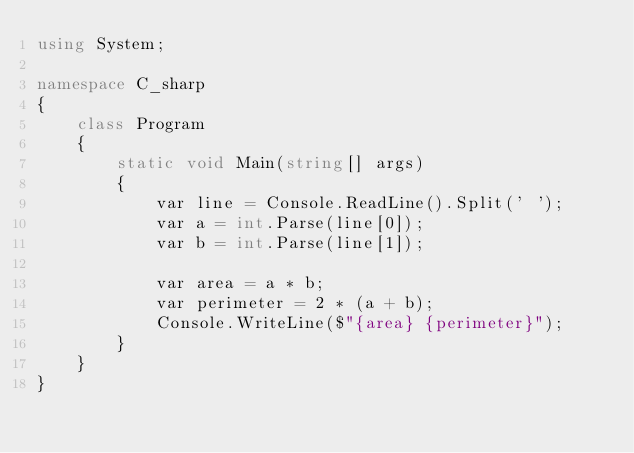Convert code to text. <code><loc_0><loc_0><loc_500><loc_500><_C#_>using System;

namespace C_sharp
{
    class Program
    {
        static void Main(string[] args)
        {
            var line = Console.ReadLine().Split(' ');
            var a = int.Parse(line[0]);
            var b = int.Parse(line[1]);

            var area = a * b;
            var perimeter = 2 * (a + b);
            Console.WriteLine($"{area} {perimeter}");
        }
    }
}

</code> 